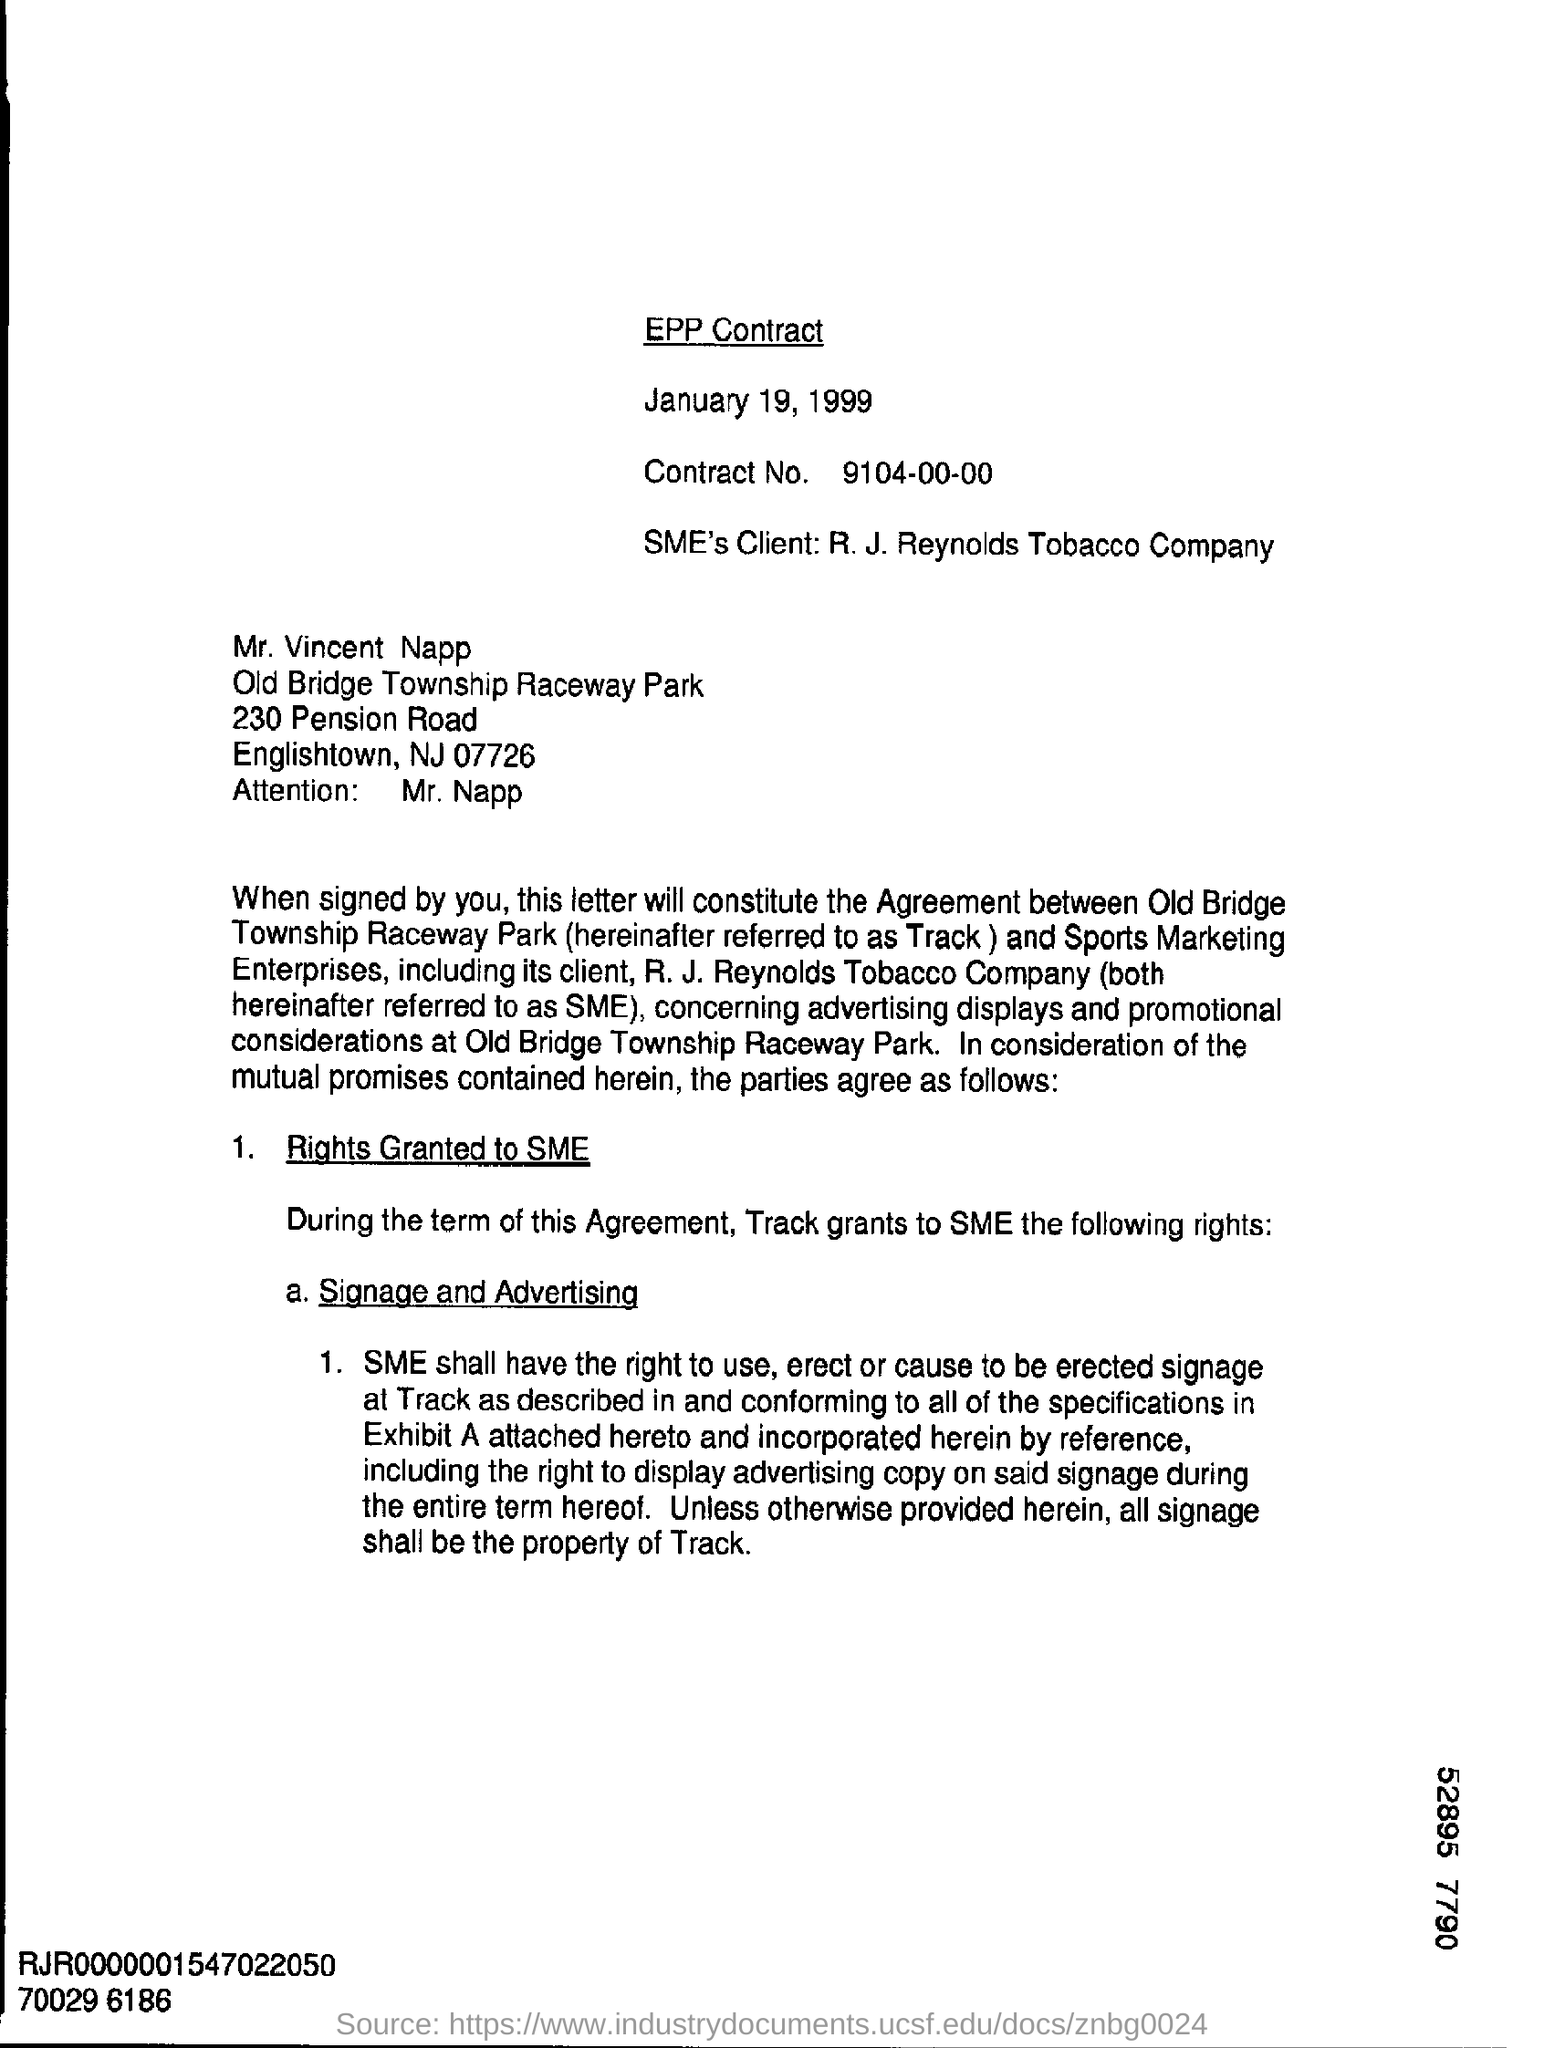Can you describe any specific details about the signage and advertising rights mentioned in the contract? While the image provided does not disclose the full details of Exhibit A, it specifies that SME's rights include the display of advertising copy on the signage erected at the Track. The signage must conform to the specifications in the agreement and incorporated by reference into Exhibit A. It is noted that while SME can display advertising during the term of the agreement, all signage will remain the property of the raceway park. 